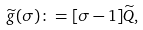<formula> <loc_0><loc_0><loc_500><loc_500>\widetilde { g } ( \sigma ) \colon = [ \sigma - 1 ] \widetilde { Q } ,</formula> 